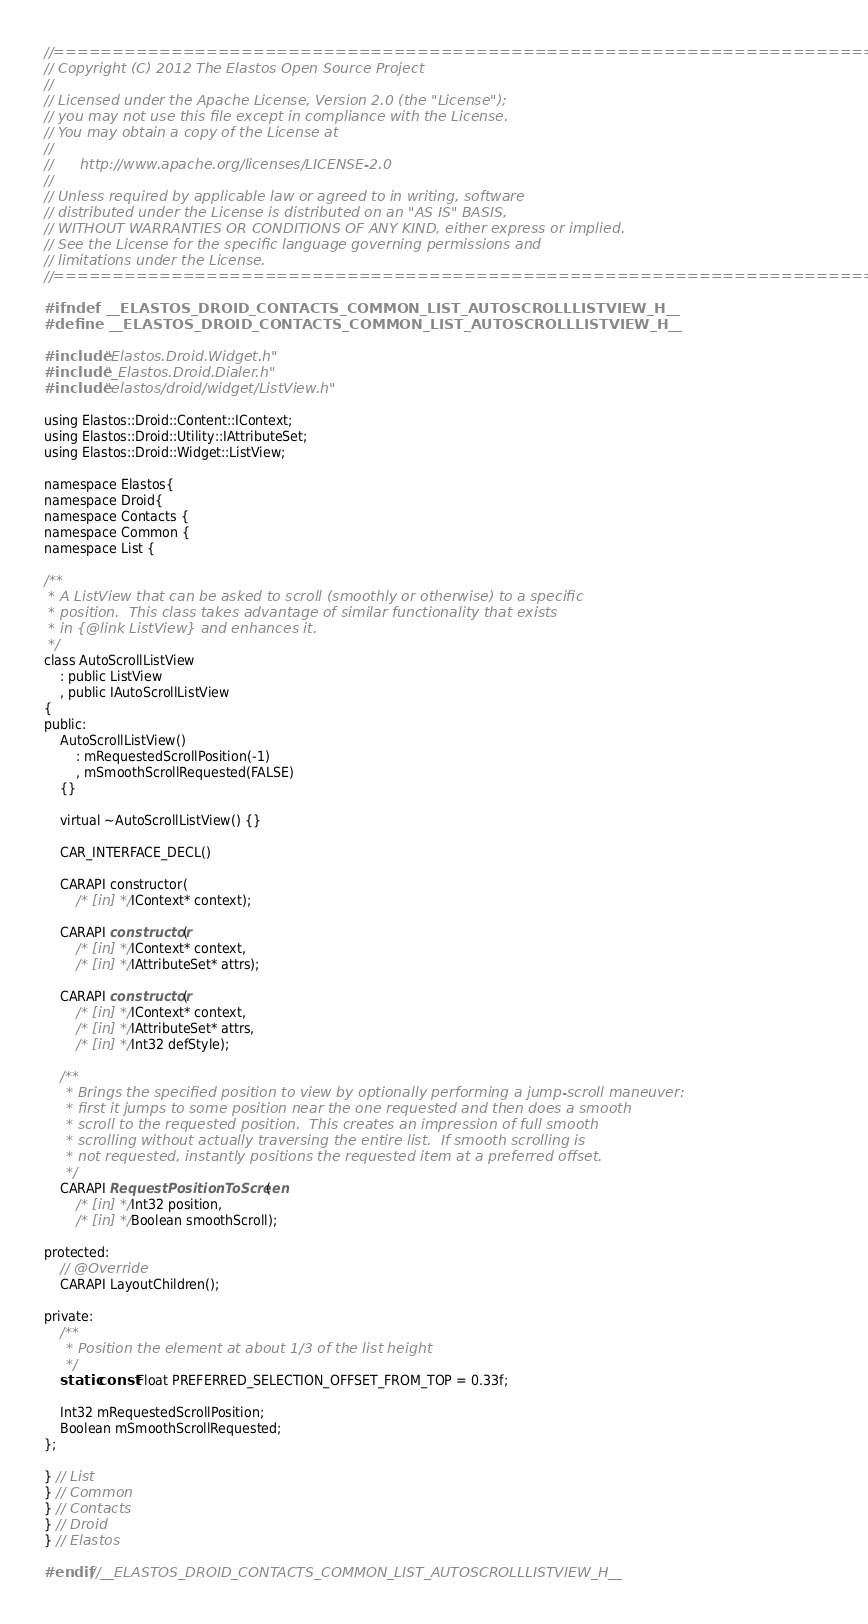<code> <loc_0><loc_0><loc_500><loc_500><_C_>//=========================================================================
// Copyright (C) 2012 The Elastos Open Source Project
//
// Licensed under the Apache License, Version 2.0 (the "License");
// you may not use this file except in compliance with the License.
// You may obtain a copy of the License at
//
//      http://www.apache.org/licenses/LICENSE-2.0
//
// Unless required by applicable law or agreed to in writing, software
// distributed under the License is distributed on an "AS IS" BASIS,
// WITHOUT WARRANTIES OR CONDITIONS OF ANY KIND, either express or implied.
// See the License for the specific language governing permissions and
// limitations under the License.
//=========================================================================

#ifndef __ELASTOS_DROID_CONTACTS_COMMON_LIST_AUTOSCROLLLISTVIEW_H__
#define __ELASTOS_DROID_CONTACTS_COMMON_LIST_AUTOSCROLLLISTVIEW_H__

#include "Elastos.Droid.Widget.h"
#include "_Elastos.Droid.Dialer.h"
#include "elastos/droid/widget/ListView.h"

using Elastos::Droid::Content::IContext;
using Elastos::Droid::Utility::IAttributeSet;
using Elastos::Droid::Widget::ListView;

namespace Elastos{
namespace Droid{
namespace Contacts {
namespace Common {
namespace List {

/**
 * A ListView that can be asked to scroll (smoothly or otherwise) to a specific
 * position.  This class takes advantage of similar functionality that exists
 * in {@link ListView} and enhances it.
 */
class AutoScrollListView
    : public ListView
    , public IAutoScrollListView
{
public:
    AutoScrollListView()
        : mRequestedScrollPosition(-1)
        , mSmoothScrollRequested(FALSE)
    {}

    virtual ~AutoScrollListView() {}

    CAR_INTERFACE_DECL()

    CARAPI constructor(
        /* [in] */ IContext* context);

    CARAPI constructor(
        /* [in] */ IContext* context,
        /* [in] */ IAttributeSet* attrs);

    CARAPI constructor(
        /* [in] */ IContext* context,
        /* [in] */ IAttributeSet* attrs,
        /* [in] */ Int32 defStyle);

    /**
     * Brings the specified position to view by optionally performing a jump-scroll maneuver:
     * first it jumps to some position near the one requested and then does a smooth
     * scroll to the requested position.  This creates an impression of full smooth
     * scrolling without actually traversing the entire list.  If smooth scrolling is
     * not requested, instantly positions the requested item at a preferred offset.
     */
    CARAPI RequestPositionToScreen(
        /* [in] */ Int32 position,
        /* [in] */ Boolean smoothScroll);

protected:
    // @Override
    CARAPI LayoutChildren();

private:
    /**
     * Position the element at about 1/3 of the list height
     */
    static const Float PREFERRED_SELECTION_OFFSET_FROM_TOP = 0.33f;

    Int32 mRequestedScrollPosition;
    Boolean mSmoothScrollRequested;
};

} // List
} // Common
} // Contacts
} // Droid
} // Elastos

#endif //__ELASTOS_DROID_CONTACTS_COMMON_LIST_AUTOSCROLLLISTVIEW_H__
</code> 